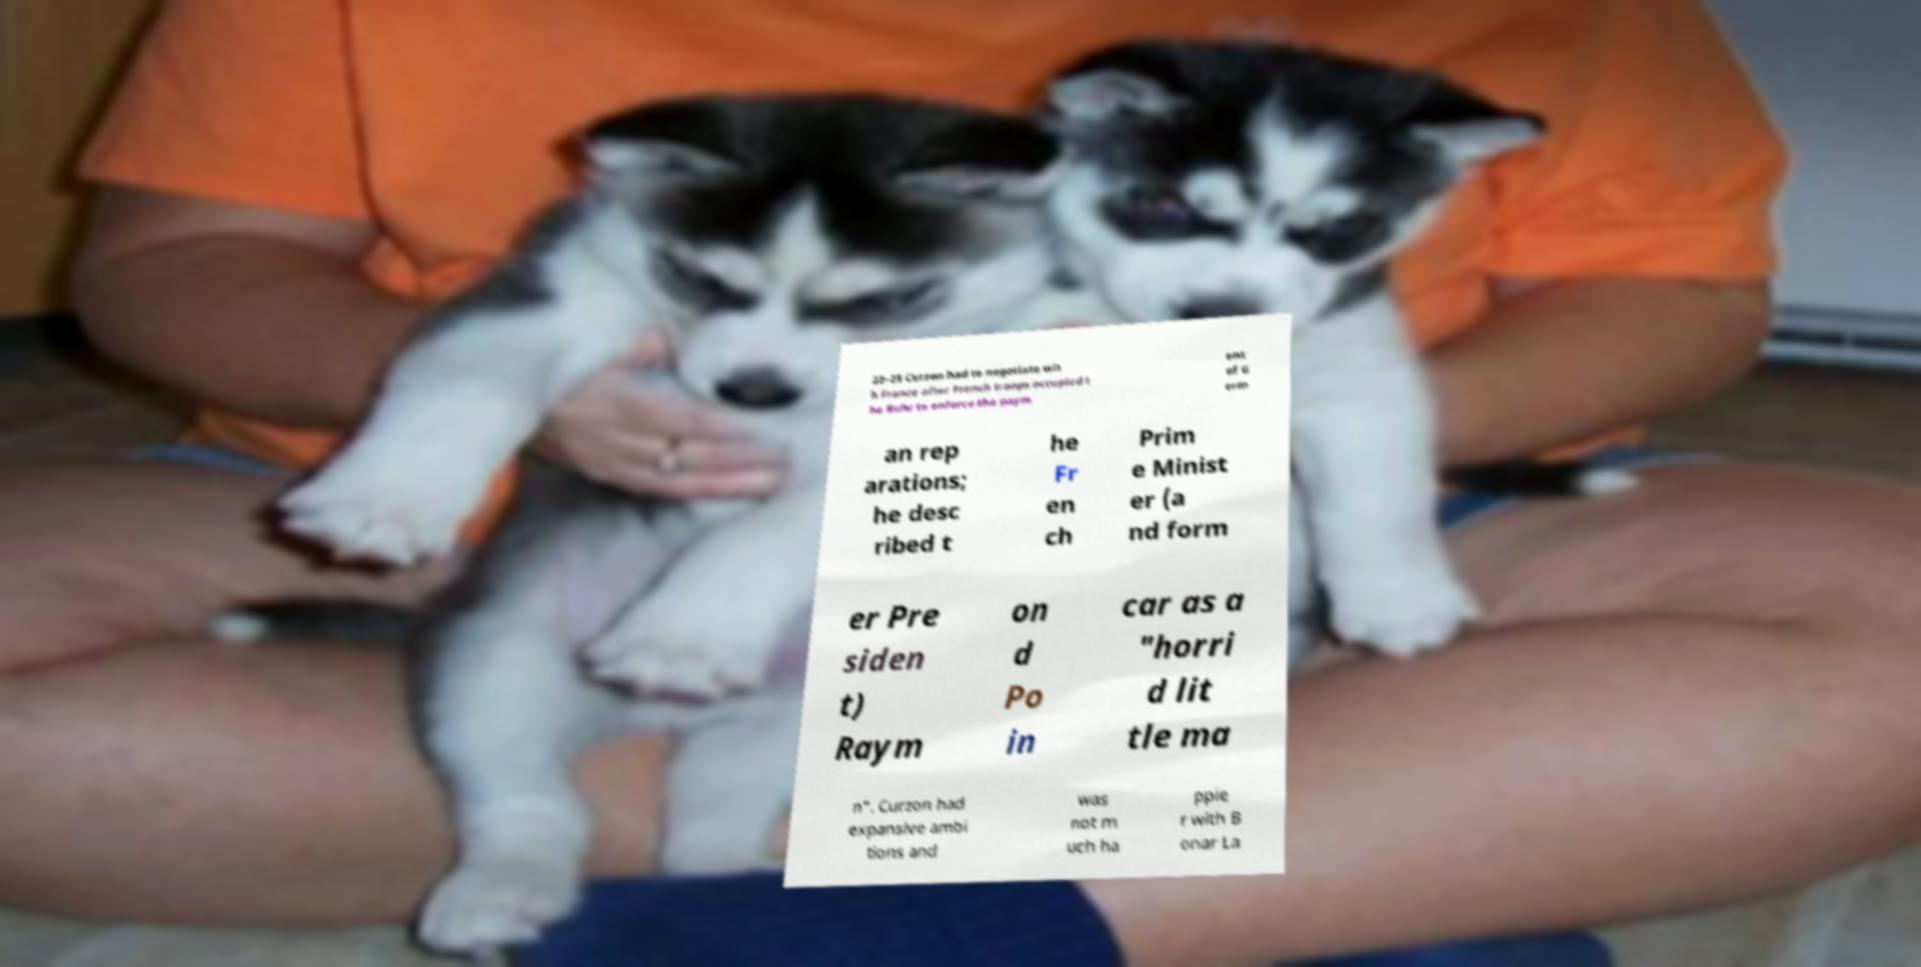There's text embedded in this image that I need extracted. Can you transcribe it verbatim? 22–23 Curzon had to negotiate wit h France after French troops occupied t he Ruhr to enforce the paym ent of G erm an rep arations; he desc ribed t he Fr en ch Prim e Minist er (a nd form er Pre siden t) Raym on d Po in car as a "horri d lit tle ma n". Curzon had expansive ambi tions and was not m uch ha ppie r with B onar La 